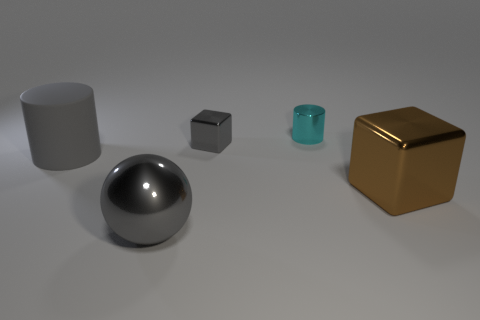Are there fewer gray objects that are in front of the gray metallic block than objects in front of the cyan metal object?
Provide a succinct answer. Yes. What size is the gray object that is in front of the big brown metal thing?
Ensure brevity in your answer.  Large. Do the cyan metal object and the gray sphere have the same size?
Offer a very short reply. No. How many metallic objects are both in front of the large gray rubber cylinder and to the right of the tiny shiny cube?
Ensure brevity in your answer.  1. How many cyan objects are large metallic blocks or small metallic things?
Keep it short and to the point. 1. How many metallic things are either purple spheres or big cubes?
Provide a succinct answer. 1. Are there any small cylinders?
Keep it short and to the point. Yes. Is the shape of the cyan metallic object the same as the big brown metallic thing?
Provide a succinct answer. No. How many metal cubes are behind the big shiny thing to the right of the cylinder that is right of the large matte cylinder?
Your answer should be very brief. 1. There is a object that is in front of the large gray rubber cylinder and on the right side of the gray sphere; what is it made of?
Your answer should be compact. Metal. 